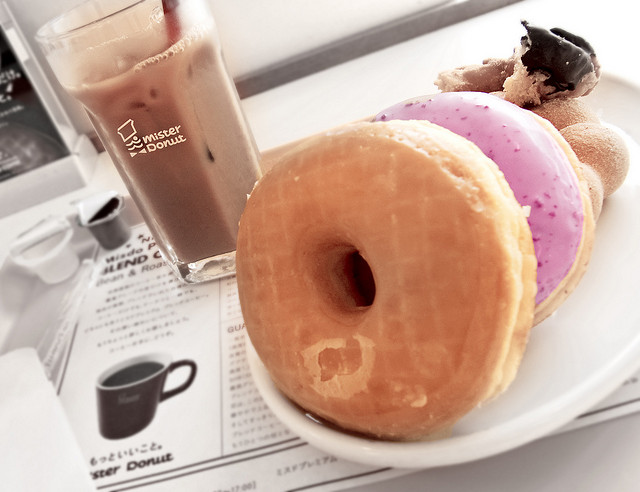Can you describe what's on the table? Sure, there's a glass of iced coffee and three donuts. One donut is coated with a glossy chocolate glaze, another appears to have a pink frosting with sprinkles, and finally, there's a classic glazed donut. 